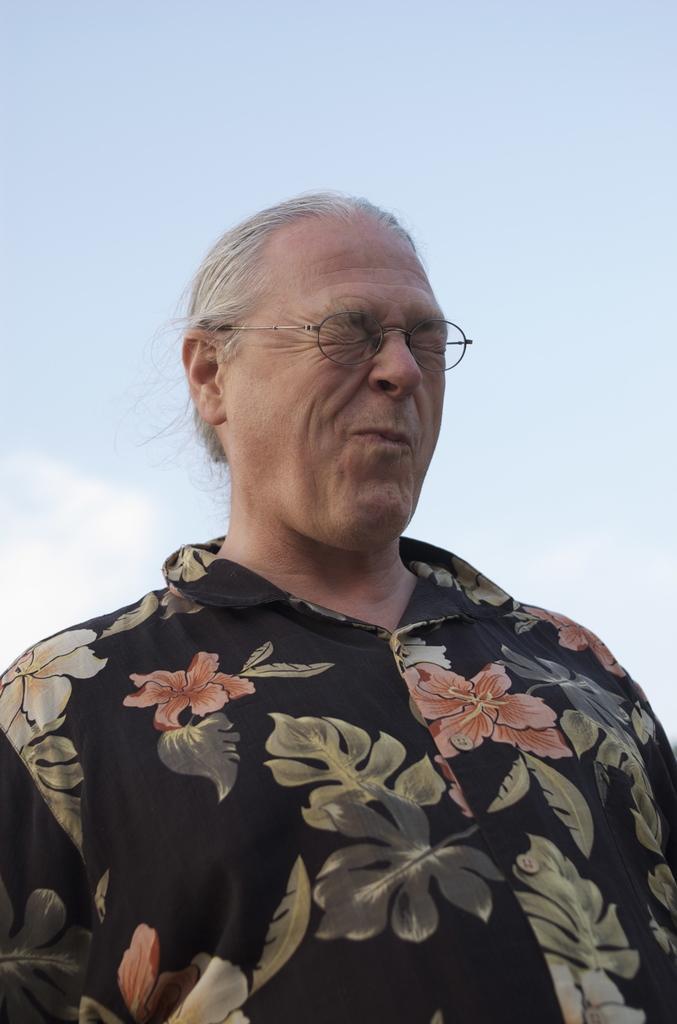How would you summarize this image in a sentence or two? In this image we can see a person standing and in the background, we can see the sky. 